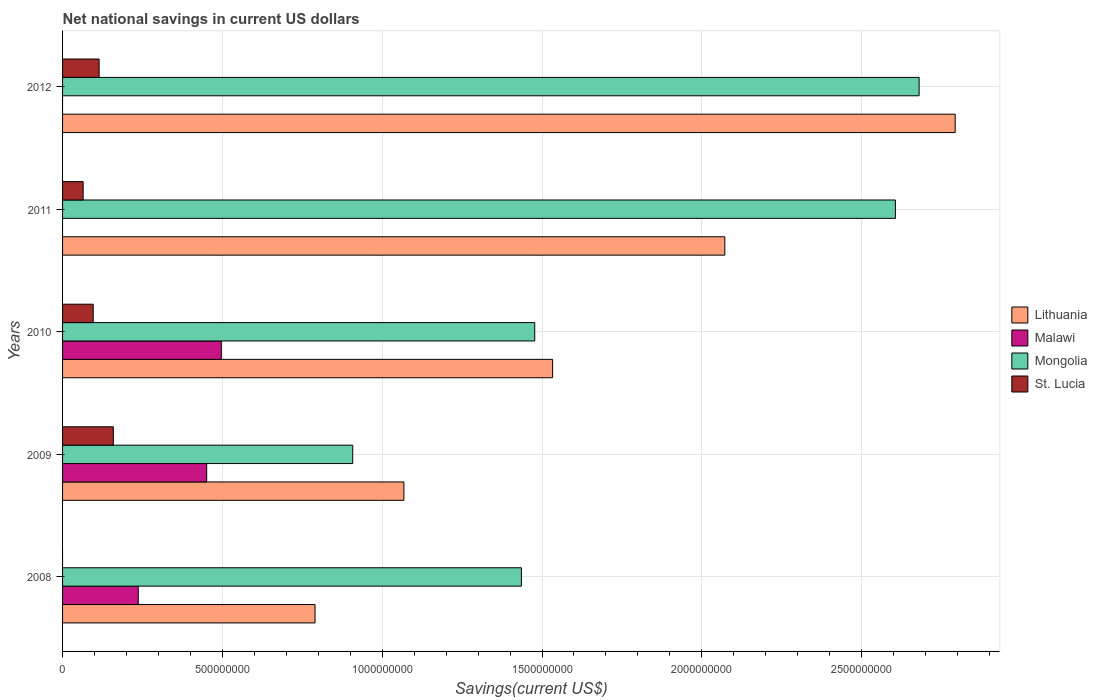How many different coloured bars are there?
Your answer should be compact. 4. How many groups of bars are there?
Give a very brief answer. 5. Are the number of bars per tick equal to the number of legend labels?
Make the answer very short. No. Are the number of bars on each tick of the Y-axis equal?
Make the answer very short. No. How many bars are there on the 4th tick from the top?
Ensure brevity in your answer.  4. What is the label of the 2nd group of bars from the top?
Provide a succinct answer. 2011. What is the net national savings in Lithuania in 2011?
Ensure brevity in your answer.  2.07e+09. Across all years, what is the maximum net national savings in Lithuania?
Provide a short and direct response. 2.79e+09. What is the total net national savings in Lithuania in the graph?
Provide a succinct answer. 8.26e+09. What is the difference between the net national savings in Mongolia in 2009 and that in 2010?
Ensure brevity in your answer.  -5.69e+08. What is the difference between the net national savings in Lithuania in 2011 and the net national savings in Mongolia in 2012?
Make the answer very short. -6.08e+08. What is the average net national savings in Mongolia per year?
Your answer should be very brief. 1.82e+09. In the year 2009, what is the difference between the net national savings in St. Lucia and net national savings in Mongolia?
Make the answer very short. -7.49e+08. What is the ratio of the net national savings in Lithuania in 2010 to that in 2012?
Provide a short and direct response. 0.55. What is the difference between the highest and the second highest net national savings in Lithuania?
Give a very brief answer. 7.21e+08. What is the difference between the highest and the lowest net national savings in Malawi?
Provide a short and direct response. 4.97e+08. Is the sum of the net national savings in Lithuania in 2008 and 2010 greater than the maximum net national savings in St. Lucia across all years?
Ensure brevity in your answer.  Yes. Is it the case that in every year, the sum of the net national savings in Mongolia and net national savings in Lithuania is greater than the net national savings in St. Lucia?
Your answer should be very brief. Yes. How many bars are there?
Your answer should be compact. 17. What is the difference between two consecutive major ticks on the X-axis?
Offer a very short reply. 5.00e+08. Are the values on the major ticks of X-axis written in scientific E-notation?
Keep it short and to the point. No. Does the graph contain any zero values?
Provide a short and direct response. Yes. Does the graph contain grids?
Provide a succinct answer. Yes. How many legend labels are there?
Your answer should be very brief. 4. How are the legend labels stacked?
Provide a succinct answer. Vertical. What is the title of the graph?
Offer a very short reply. Net national savings in current US dollars. What is the label or title of the X-axis?
Provide a succinct answer. Savings(current US$). What is the Savings(current US$) in Lithuania in 2008?
Offer a terse response. 7.90e+08. What is the Savings(current US$) of Malawi in 2008?
Offer a very short reply. 2.37e+08. What is the Savings(current US$) of Mongolia in 2008?
Offer a terse response. 1.44e+09. What is the Savings(current US$) in St. Lucia in 2008?
Your answer should be very brief. 0. What is the Savings(current US$) in Lithuania in 2009?
Offer a terse response. 1.07e+09. What is the Savings(current US$) in Malawi in 2009?
Offer a very short reply. 4.51e+08. What is the Savings(current US$) of Mongolia in 2009?
Your answer should be very brief. 9.08e+08. What is the Savings(current US$) of St. Lucia in 2009?
Give a very brief answer. 1.59e+08. What is the Savings(current US$) of Lithuania in 2010?
Your answer should be compact. 1.53e+09. What is the Savings(current US$) in Malawi in 2010?
Your response must be concise. 4.97e+08. What is the Savings(current US$) in Mongolia in 2010?
Offer a terse response. 1.48e+09. What is the Savings(current US$) in St. Lucia in 2010?
Provide a succinct answer. 9.59e+07. What is the Savings(current US$) in Lithuania in 2011?
Provide a short and direct response. 2.07e+09. What is the Savings(current US$) of Mongolia in 2011?
Give a very brief answer. 2.61e+09. What is the Savings(current US$) of St. Lucia in 2011?
Your answer should be compact. 6.44e+07. What is the Savings(current US$) in Lithuania in 2012?
Your response must be concise. 2.79e+09. What is the Savings(current US$) of Mongolia in 2012?
Your response must be concise. 2.68e+09. What is the Savings(current US$) of St. Lucia in 2012?
Provide a succinct answer. 1.14e+08. Across all years, what is the maximum Savings(current US$) of Lithuania?
Your answer should be compact. 2.79e+09. Across all years, what is the maximum Savings(current US$) of Malawi?
Your answer should be compact. 4.97e+08. Across all years, what is the maximum Savings(current US$) in Mongolia?
Provide a short and direct response. 2.68e+09. Across all years, what is the maximum Savings(current US$) of St. Lucia?
Provide a short and direct response. 1.59e+08. Across all years, what is the minimum Savings(current US$) in Lithuania?
Your answer should be very brief. 7.90e+08. Across all years, what is the minimum Savings(current US$) in Mongolia?
Provide a succinct answer. 9.08e+08. What is the total Savings(current US$) in Lithuania in the graph?
Keep it short and to the point. 8.26e+09. What is the total Savings(current US$) in Malawi in the graph?
Your answer should be compact. 1.18e+09. What is the total Savings(current US$) of Mongolia in the graph?
Offer a very short reply. 9.11e+09. What is the total Savings(current US$) of St. Lucia in the graph?
Your response must be concise. 4.33e+08. What is the difference between the Savings(current US$) of Lithuania in 2008 and that in 2009?
Provide a succinct answer. -2.78e+08. What is the difference between the Savings(current US$) in Malawi in 2008 and that in 2009?
Keep it short and to the point. -2.14e+08. What is the difference between the Savings(current US$) in Mongolia in 2008 and that in 2009?
Provide a short and direct response. 5.28e+08. What is the difference between the Savings(current US$) in Lithuania in 2008 and that in 2010?
Ensure brevity in your answer.  -7.43e+08. What is the difference between the Savings(current US$) in Malawi in 2008 and that in 2010?
Offer a terse response. -2.60e+08. What is the difference between the Savings(current US$) of Mongolia in 2008 and that in 2010?
Your answer should be compact. -4.17e+07. What is the difference between the Savings(current US$) in Lithuania in 2008 and that in 2011?
Offer a terse response. -1.28e+09. What is the difference between the Savings(current US$) of Mongolia in 2008 and that in 2011?
Ensure brevity in your answer.  -1.17e+09. What is the difference between the Savings(current US$) in Lithuania in 2008 and that in 2012?
Offer a very short reply. -2.00e+09. What is the difference between the Savings(current US$) in Mongolia in 2008 and that in 2012?
Your answer should be compact. -1.24e+09. What is the difference between the Savings(current US$) of Lithuania in 2009 and that in 2010?
Your answer should be very brief. -4.65e+08. What is the difference between the Savings(current US$) in Malawi in 2009 and that in 2010?
Make the answer very short. -4.57e+07. What is the difference between the Savings(current US$) of Mongolia in 2009 and that in 2010?
Ensure brevity in your answer.  -5.69e+08. What is the difference between the Savings(current US$) in St. Lucia in 2009 and that in 2010?
Your answer should be compact. 6.29e+07. What is the difference between the Savings(current US$) in Lithuania in 2009 and that in 2011?
Provide a short and direct response. -1.00e+09. What is the difference between the Savings(current US$) of Mongolia in 2009 and that in 2011?
Your response must be concise. -1.70e+09. What is the difference between the Savings(current US$) of St. Lucia in 2009 and that in 2011?
Make the answer very short. 9.44e+07. What is the difference between the Savings(current US$) in Lithuania in 2009 and that in 2012?
Offer a very short reply. -1.72e+09. What is the difference between the Savings(current US$) in Mongolia in 2009 and that in 2012?
Your answer should be compact. -1.77e+09. What is the difference between the Savings(current US$) of St. Lucia in 2009 and that in 2012?
Ensure brevity in your answer.  4.44e+07. What is the difference between the Savings(current US$) in Lithuania in 2010 and that in 2011?
Your answer should be very brief. -5.39e+08. What is the difference between the Savings(current US$) in Mongolia in 2010 and that in 2011?
Your response must be concise. -1.13e+09. What is the difference between the Savings(current US$) in St. Lucia in 2010 and that in 2011?
Offer a terse response. 3.15e+07. What is the difference between the Savings(current US$) in Lithuania in 2010 and that in 2012?
Ensure brevity in your answer.  -1.26e+09. What is the difference between the Savings(current US$) of Mongolia in 2010 and that in 2012?
Provide a succinct answer. -1.20e+09. What is the difference between the Savings(current US$) of St. Lucia in 2010 and that in 2012?
Give a very brief answer. -1.85e+07. What is the difference between the Savings(current US$) in Lithuania in 2011 and that in 2012?
Your answer should be very brief. -7.21e+08. What is the difference between the Savings(current US$) in Mongolia in 2011 and that in 2012?
Your answer should be compact. -7.42e+07. What is the difference between the Savings(current US$) of St. Lucia in 2011 and that in 2012?
Your answer should be very brief. -5.00e+07. What is the difference between the Savings(current US$) of Lithuania in 2008 and the Savings(current US$) of Malawi in 2009?
Your answer should be very brief. 3.39e+08. What is the difference between the Savings(current US$) of Lithuania in 2008 and the Savings(current US$) of Mongolia in 2009?
Offer a very short reply. -1.18e+08. What is the difference between the Savings(current US$) in Lithuania in 2008 and the Savings(current US$) in St. Lucia in 2009?
Give a very brief answer. 6.31e+08. What is the difference between the Savings(current US$) in Malawi in 2008 and the Savings(current US$) in Mongolia in 2009?
Provide a short and direct response. -6.71e+08. What is the difference between the Savings(current US$) of Malawi in 2008 and the Savings(current US$) of St. Lucia in 2009?
Ensure brevity in your answer.  7.80e+07. What is the difference between the Savings(current US$) in Mongolia in 2008 and the Savings(current US$) in St. Lucia in 2009?
Keep it short and to the point. 1.28e+09. What is the difference between the Savings(current US$) of Lithuania in 2008 and the Savings(current US$) of Malawi in 2010?
Keep it short and to the point. 2.93e+08. What is the difference between the Savings(current US$) in Lithuania in 2008 and the Savings(current US$) in Mongolia in 2010?
Make the answer very short. -6.87e+08. What is the difference between the Savings(current US$) of Lithuania in 2008 and the Savings(current US$) of St. Lucia in 2010?
Make the answer very short. 6.94e+08. What is the difference between the Savings(current US$) of Malawi in 2008 and the Savings(current US$) of Mongolia in 2010?
Your answer should be compact. -1.24e+09. What is the difference between the Savings(current US$) of Malawi in 2008 and the Savings(current US$) of St. Lucia in 2010?
Give a very brief answer. 1.41e+08. What is the difference between the Savings(current US$) in Mongolia in 2008 and the Savings(current US$) in St. Lucia in 2010?
Offer a terse response. 1.34e+09. What is the difference between the Savings(current US$) in Lithuania in 2008 and the Savings(current US$) in Mongolia in 2011?
Your answer should be very brief. -1.82e+09. What is the difference between the Savings(current US$) in Lithuania in 2008 and the Savings(current US$) in St. Lucia in 2011?
Make the answer very short. 7.25e+08. What is the difference between the Savings(current US$) in Malawi in 2008 and the Savings(current US$) in Mongolia in 2011?
Give a very brief answer. -2.37e+09. What is the difference between the Savings(current US$) of Malawi in 2008 and the Savings(current US$) of St. Lucia in 2011?
Provide a succinct answer. 1.72e+08. What is the difference between the Savings(current US$) of Mongolia in 2008 and the Savings(current US$) of St. Lucia in 2011?
Your answer should be compact. 1.37e+09. What is the difference between the Savings(current US$) of Lithuania in 2008 and the Savings(current US$) of Mongolia in 2012?
Offer a very short reply. -1.89e+09. What is the difference between the Savings(current US$) of Lithuania in 2008 and the Savings(current US$) of St. Lucia in 2012?
Provide a short and direct response. 6.75e+08. What is the difference between the Savings(current US$) of Malawi in 2008 and the Savings(current US$) of Mongolia in 2012?
Your answer should be very brief. -2.44e+09. What is the difference between the Savings(current US$) in Malawi in 2008 and the Savings(current US$) in St. Lucia in 2012?
Offer a very short reply. 1.22e+08. What is the difference between the Savings(current US$) of Mongolia in 2008 and the Savings(current US$) of St. Lucia in 2012?
Give a very brief answer. 1.32e+09. What is the difference between the Savings(current US$) in Lithuania in 2009 and the Savings(current US$) in Malawi in 2010?
Your answer should be very brief. 5.71e+08. What is the difference between the Savings(current US$) of Lithuania in 2009 and the Savings(current US$) of Mongolia in 2010?
Provide a succinct answer. -4.09e+08. What is the difference between the Savings(current US$) in Lithuania in 2009 and the Savings(current US$) in St. Lucia in 2010?
Make the answer very short. 9.72e+08. What is the difference between the Savings(current US$) in Malawi in 2009 and the Savings(current US$) in Mongolia in 2010?
Give a very brief answer. -1.03e+09. What is the difference between the Savings(current US$) in Malawi in 2009 and the Savings(current US$) in St. Lucia in 2010?
Offer a terse response. 3.55e+08. What is the difference between the Savings(current US$) of Mongolia in 2009 and the Savings(current US$) of St. Lucia in 2010?
Offer a very short reply. 8.12e+08. What is the difference between the Savings(current US$) in Lithuania in 2009 and the Savings(current US$) in Mongolia in 2011?
Give a very brief answer. -1.54e+09. What is the difference between the Savings(current US$) in Lithuania in 2009 and the Savings(current US$) in St. Lucia in 2011?
Offer a very short reply. 1.00e+09. What is the difference between the Savings(current US$) in Malawi in 2009 and the Savings(current US$) in Mongolia in 2011?
Offer a terse response. -2.15e+09. What is the difference between the Savings(current US$) of Malawi in 2009 and the Savings(current US$) of St. Lucia in 2011?
Make the answer very short. 3.87e+08. What is the difference between the Savings(current US$) of Mongolia in 2009 and the Savings(current US$) of St. Lucia in 2011?
Offer a terse response. 8.43e+08. What is the difference between the Savings(current US$) of Lithuania in 2009 and the Savings(current US$) of Mongolia in 2012?
Provide a succinct answer. -1.61e+09. What is the difference between the Savings(current US$) in Lithuania in 2009 and the Savings(current US$) in St. Lucia in 2012?
Offer a terse response. 9.53e+08. What is the difference between the Savings(current US$) of Malawi in 2009 and the Savings(current US$) of Mongolia in 2012?
Offer a terse response. -2.23e+09. What is the difference between the Savings(current US$) of Malawi in 2009 and the Savings(current US$) of St. Lucia in 2012?
Your answer should be very brief. 3.37e+08. What is the difference between the Savings(current US$) of Mongolia in 2009 and the Savings(current US$) of St. Lucia in 2012?
Give a very brief answer. 7.93e+08. What is the difference between the Savings(current US$) in Lithuania in 2010 and the Savings(current US$) in Mongolia in 2011?
Offer a terse response. -1.07e+09. What is the difference between the Savings(current US$) in Lithuania in 2010 and the Savings(current US$) in St. Lucia in 2011?
Provide a succinct answer. 1.47e+09. What is the difference between the Savings(current US$) in Malawi in 2010 and the Savings(current US$) in Mongolia in 2011?
Offer a very short reply. -2.11e+09. What is the difference between the Savings(current US$) of Malawi in 2010 and the Savings(current US$) of St. Lucia in 2011?
Provide a short and direct response. 4.32e+08. What is the difference between the Savings(current US$) of Mongolia in 2010 and the Savings(current US$) of St. Lucia in 2011?
Offer a very short reply. 1.41e+09. What is the difference between the Savings(current US$) in Lithuania in 2010 and the Savings(current US$) in Mongolia in 2012?
Ensure brevity in your answer.  -1.15e+09. What is the difference between the Savings(current US$) of Lithuania in 2010 and the Savings(current US$) of St. Lucia in 2012?
Your answer should be very brief. 1.42e+09. What is the difference between the Savings(current US$) of Malawi in 2010 and the Savings(current US$) of Mongolia in 2012?
Keep it short and to the point. -2.18e+09. What is the difference between the Savings(current US$) in Malawi in 2010 and the Savings(current US$) in St. Lucia in 2012?
Ensure brevity in your answer.  3.82e+08. What is the difference between the Savings(current US$) of Mongolia in 2010 and the Savings(current US$) of St. Lucia in 2012?
Make the answer very short. 1.36e+09. What is the difference between the Savings(current US$) in Lithuania in 2011 and the Savings(current US$) in Mongolia in 2012?
Offer a terse response. -6.08e+08. What is the difference between the Savings(current US$) of Lithuania in 2011 and the Savings(current US$) of St. Lucia in 2012?
Make the answer very short. 1.96e+09. What is the difference between the Savings(current US$) of Mongolia in 2011 and the Savings(current US$) of St. Lucia in 2012?
Your response must be concise. 2.49e+09. What is the average Savings(current US$) in Lithuania per year?
Keep it short and to the point. 1.65e+09. What is the average Savings(current US$) in Malawi per year?
Provide a succinct answer. 2.37e+08. What is the average Savings(current US$) of Mongolia per year?
Keep it short and to the point. 1.82e+09. What is the average Savings(current US$) of St. Lucia per year?
Make the answer very short. 8.67e+07. In the year 2008, what is the difference between the Savings(current US$) in Lithuania and Savings(current US$) in Malawi?
Ensure brevity in your answer.  5.53e+08. In the year 2008, what is the difference between the Savings(current US$) in Lithuania and Savings(current US$) in Mongolia?
Keep it short and to the point. -6.46e+08. In the year 2008, what is the difference between the Savings(current US$) of Malawi and Savings(current US$) of Mongolia?
Your response must be concise. -1.20e+09. In the year 2009, what is the difference between the Savings(current US$) of Lithuania and Savings(current US$) of Malawi?
Provide a short and direct response. 6.17e+08. In the year 2009, what is the difference between the Savings(current US$) of Lithuania and Savings(current US$) of Mongolia?
Keep it short and to the point. 1.60e+08. In the year 2009, what is the difference between the Savings(current US$) in Lithuania and Savings(current US$) in St. Lucia?
Make the answer very short. 9.09e+08. In the year 2009, what is the difference between the Savings(current US$) in Malawi and Savings(current US$) in Mongolia?
Offer a very short reply. -4.57e+08. In the year 2009, what is the difference between the Savings(current US$) of Malawi and Savings(current US$) of St. Lucia?
Keep it short and to the point. 2.92e+08. In the year 2009, what is the difference between the Savings(current US$) in Mongolia and Savings(current US$) in St. Lucia?
Give a very brief answer. 7.49e+08. In the year 2010, what is the difference between the Savings(current US$) of Lithuania and Savings(current US$) of Malawi?
Your answer should be very brief. 1.04e+09. In the year 2010, what is the difference between the Savings(current US$) in Lithuania and Savings(current US$) in Mongolia?
Provide a short and direct response. 5.60e+07. In the year 2010, what is the difference between the Savings(current US$) of Lithuania and Savings(current US$) of St. Lucia?
Provide a short and direct response. 1.44e+09. In the year 2010, what is the difference between the Savings(current US$) of Malawi and Savings(current US$) of Mongolia?
Give a very brief answer. -9.81e+08. In the year 2010, what is the difference between the Savings(current US$) in Malawi and Savings(current US$) in St. Lucia?
Give a very brief answer. 4.01e+08. In the year 2010, what is the difference between the Savings(current US$) in Mongolia and Savings(current US$) in St. Lucia?
Make the answer very short. 1.38e+09. In the year 2011, what is the difference between the Savings(current US$) of Lithuania and Savings(current US$) of Mongolia?
Your response must be concise. -5.34e+08. In the year 2011, what is the difference between the Savings(current US$) in Lithuania and Savings(current US$) in St. Lucia?
Provide a short and direct response. 2.01e+09. In the year 2011, what is the difference between the Savings(current US$) in Mongolia and Savings(current US$) in St. Lucia?
Offer a terse response. 2.54e+09. In the year 2012, what is the difference between the Savings(current US$) of Lithuania and Savings(current US$) of Mongolia?
Provide a short and direct response. 1.13e+08. In the year 2012, what is the difference between the Savings(current US$) in Lithuania and Savings(current US$) in St. Lucia?
Give a very brief answer. 2.68e+09. In the year 2012, what is the difference between the Savings(current US$) in Mongolia and Savings(current US$) in St. Lucia?
Give a very brief answer. 2.57e+09. What is the ratio of the Savings(current US$) of Lithuania in 2008 to that in 2009?
Provide a short and direct response. 0.74. What is the ratio of the Savings(current US$) in Malawi in 2008 to that in 2009?
Your response must be concise. 0.53. What is the ratio of the Savings(current US$) of Mongolia in 2008 to that in 2009?
Your answer should be compact. 1.58. What is the ratio of the Savings(current US$) in Lithuania in 2008 to that in 2010?
Keep it short and to the point. 0.52. What is the ratio of the Savings(current US$) of Malawi in 2008 to that in 2010?
Keep it short and to the point. 0.48. What is the ratio of the Savings(current US$) in Mongolia in 2008 to that in 2010?
Give a very brief answer. 0.97. What is the ratio of the Savings(current US$) of Lithuania in 2008 to that in 2011?
Make the answer very short. 0.38. What is the ratio of the Savings(current US$) of Mongolia in 2008 to that in 2011?
Provide a short and direct response. 0.55. What is the ratio of the Savings(current US$) of Lithuania in 2008 to that in 2012?
Provide a short and direct response. 0.28. What is the ratio of the Savings(current US$) in Mongolia in 2008 to that in 2012?
Your response must be concise. 0.54. What is the ratio of the Savings(current US$) in Lithuania in 2009 to that in 2010?
Your answer should be very brief. 0.7. What is the ratio of the Savings(current US$) in Malawi in 2009 to that in 2010?
Your answer should be very brief. 0.91. What is the ratio of the Savings(current US$) in Mongolia in 2009 to that in 2010?
Make the answer very short. 0.61. What is the ratio of the Savings(current US$) in St. Lucia in 2009 to that in 2010?
Provide a succinct answer. 1.66. What is the ratio of the Savings(current US$) in Lithuania in 2009 to that in 2011?
Offer a terse response. 0.52. What is the ratio of the Savings(current US$) in Mongolia in 2009 to that in 2011?
Give a very brief answer. 0.35. What is the ratio of the Savings(current US$) in St. Lucia in 2009 to that in 2011?
Provide a short and direct response. 2.47. What is the ratio of the Savings(current US$) of Lithuania in 2009 to that in 2012?
Ensure brevity in your answer.  0.38. What is the ratio of the Savings(current US$) in Mongolia in 2009 to that in 2012?
Offer a terse response. 0.34. What is the ratio of the Savings(current US$) in St. Lucia in 2009 to that in 2012?
Keep it short and to the point. 1.39. What is the ratio of the Savings(current US$) in Lithuania in 2010 to that in 2011?
Give a very brief answer. 0.74. What is the ratio of the Savings(current US$) in Mongolia in 2010 to that in 2011?
Your answer should be compact. 0.57. What is the ratio of the Savings(current US$) in St. Lucia in 2010 to that in 2011?
Offer a very short reply. 1.49. What is the ratio of the Savings(current US$) in Lithuania in 2010 to that in 2012?
Give a very brief answer. 0.55. What is the ratio of the Savings(current US$) of Mongolia in 2010 to that in 2012?
Your response must be concise. 0.55. What is the ratio of the Savings(current US$) in St. Lucia in 2010 to that in 2012?
Keep it short and to the point. 0.84. What is the ratio of the Savings(current US$) in Lithuania in 2011 to that in 2012?
Keep it short and to the point. 0.74. What is the ratio of the Savings(current US$) in Mongolia in 2011 to that in 2012?
Keep it short and to the point. 0.97. What is the ratio of the Savings(current US$) in St. Lucia in 2011 to that in 2012?
Offer a terse response. 0.56. What is the difference between the highest and the second highest Savings(current US$) in Lithuania?
Your response must be concise. 7.21e+08. What is the difference between the highest and the second highest Savings(current US$) of Malawi?
Offer a terse response. 4.57e+07. What is the difference between the highest and the second highest Savings(current US$) in Mongolia?
Keep it short and to the point. 7.42e+07. What is the difference between the highest and the second highest Savings(current US$) in St. Lucia?
Your answer should be compact. 4.44e+07. What is the difference between the highest and the lowest Savings(current US$) in Lithuania?
Keep it short and to the point. 2.00e+09. What is the difference between the highest and the lowest Savings(current US$) in Malawi?
Give a very brief answer. 4.97e+08. What is the difference between the highest and the lowest Savings(current US$) in Mongolia?
Your answer should be very brief. 1.77e+09. What is the difference between the highest and the lowest Savings(current US$) in St. Lucia?
Provide a short and direct response. 1.59e+08. 